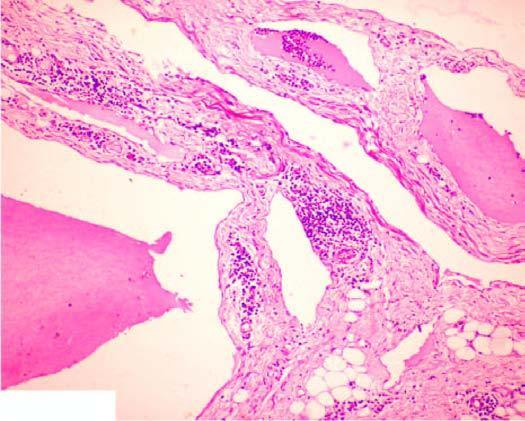re large cystic spaces lined by the flattened endothelial cells and containing lymph present?
Answer the question using a single word or phrase. Yes 